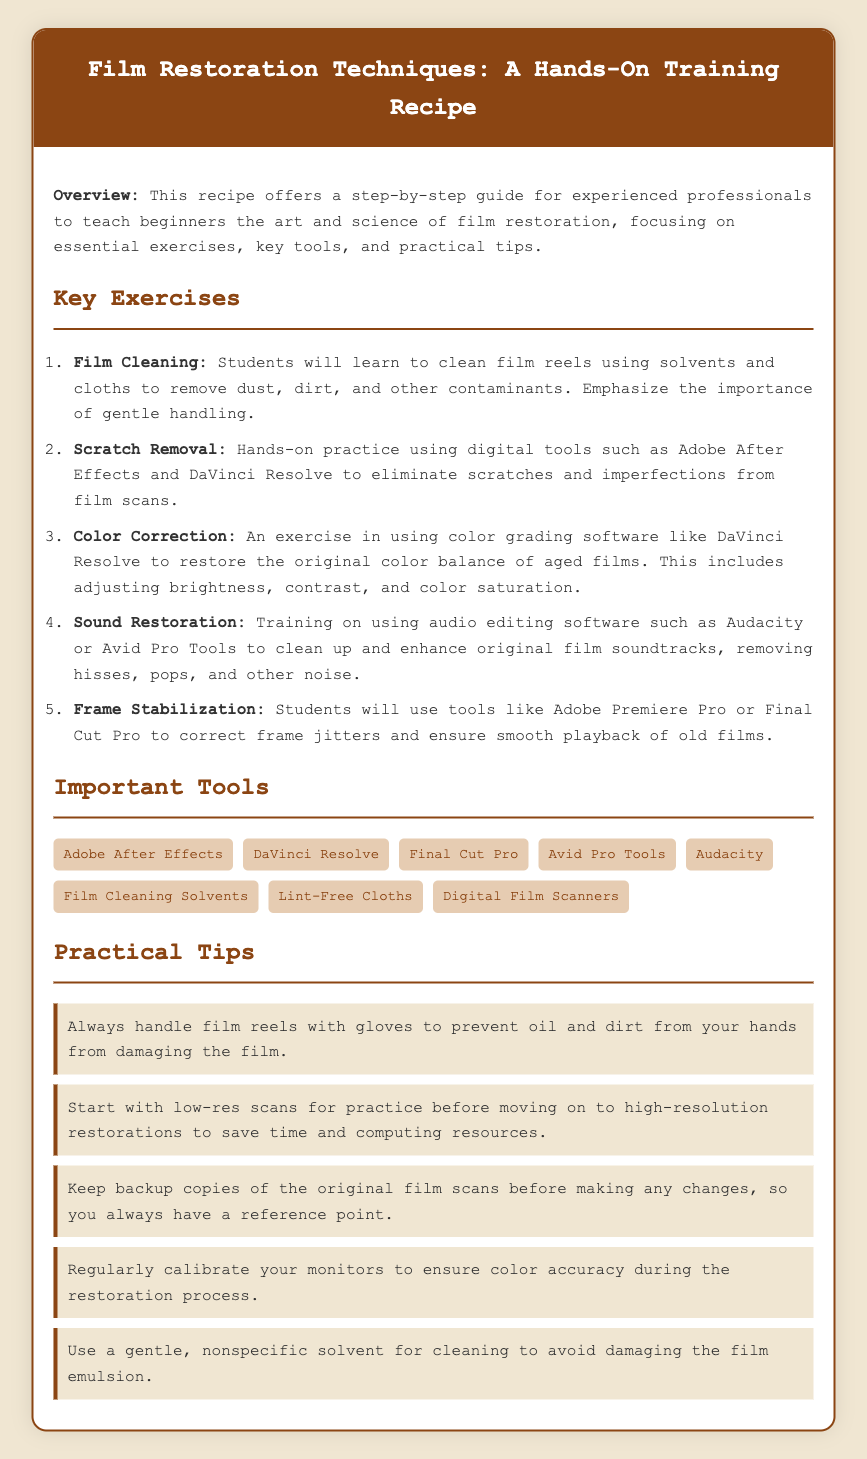What is the title of the document? The title is prominently displayed at the top of the document as the main header.
Answer: Film Restoration Techniques: A Hands-On Training Recipe How many key exercises are listed? The number of key exercises can be found by counting the items in the ordered list under "Key Exercises."
Answer: 5 Which software is used for sound restoration? The software mentioned under the "Sound Restoration" exercise specifically addresses audio editing capabilities.
Answer: Audacity or Avid Pro Tools What type of cloth should be used for film cleaning? The relevant section highlights specific cleaning materials that should be used for handling film.
Answer: Lint-Free Cloths Name one important tool mentioned for film cleaning. The tools listed are critical for the cleaning process and can be found in the "Important Tools" section.
Answer: Film Cleaning Solvents What is a practical tip regarding film handling? The practical tips section includes advice on handling film to avoid damage, found in the tips provided.
Answer: Always handle film reels with gloves Which software is mentioned first in the list of important tools? The order of the tools is important, and the first entry provides the required information.
Answer: Adobe After Effects What should be done before making changes to film scans? The tips emphasize the importance of precautions when working with film, specifically before alterations.
Answer: Keep backup copies of the original film scans 